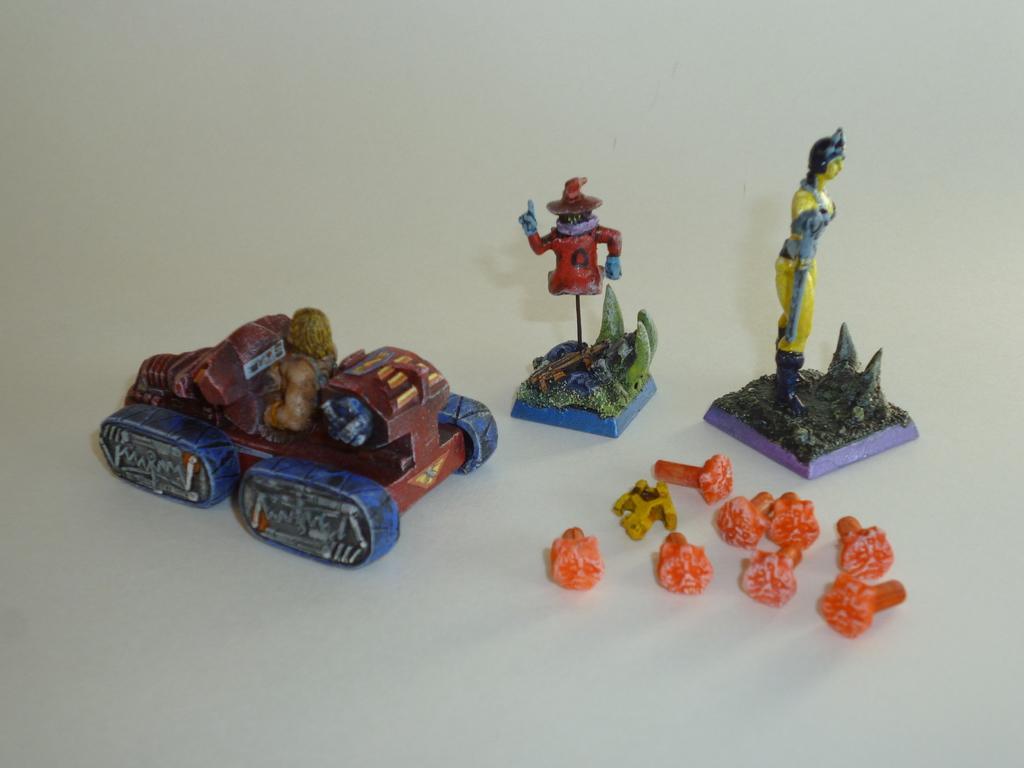How would you summarize this image in a sentence or two? In this picture, we see a toy car in blue and brown color. Beside that, we see toys in red and yellow color. In front of the picture, we see the objects in orange color. These objects look like the nails. In the background, it is white in color. 